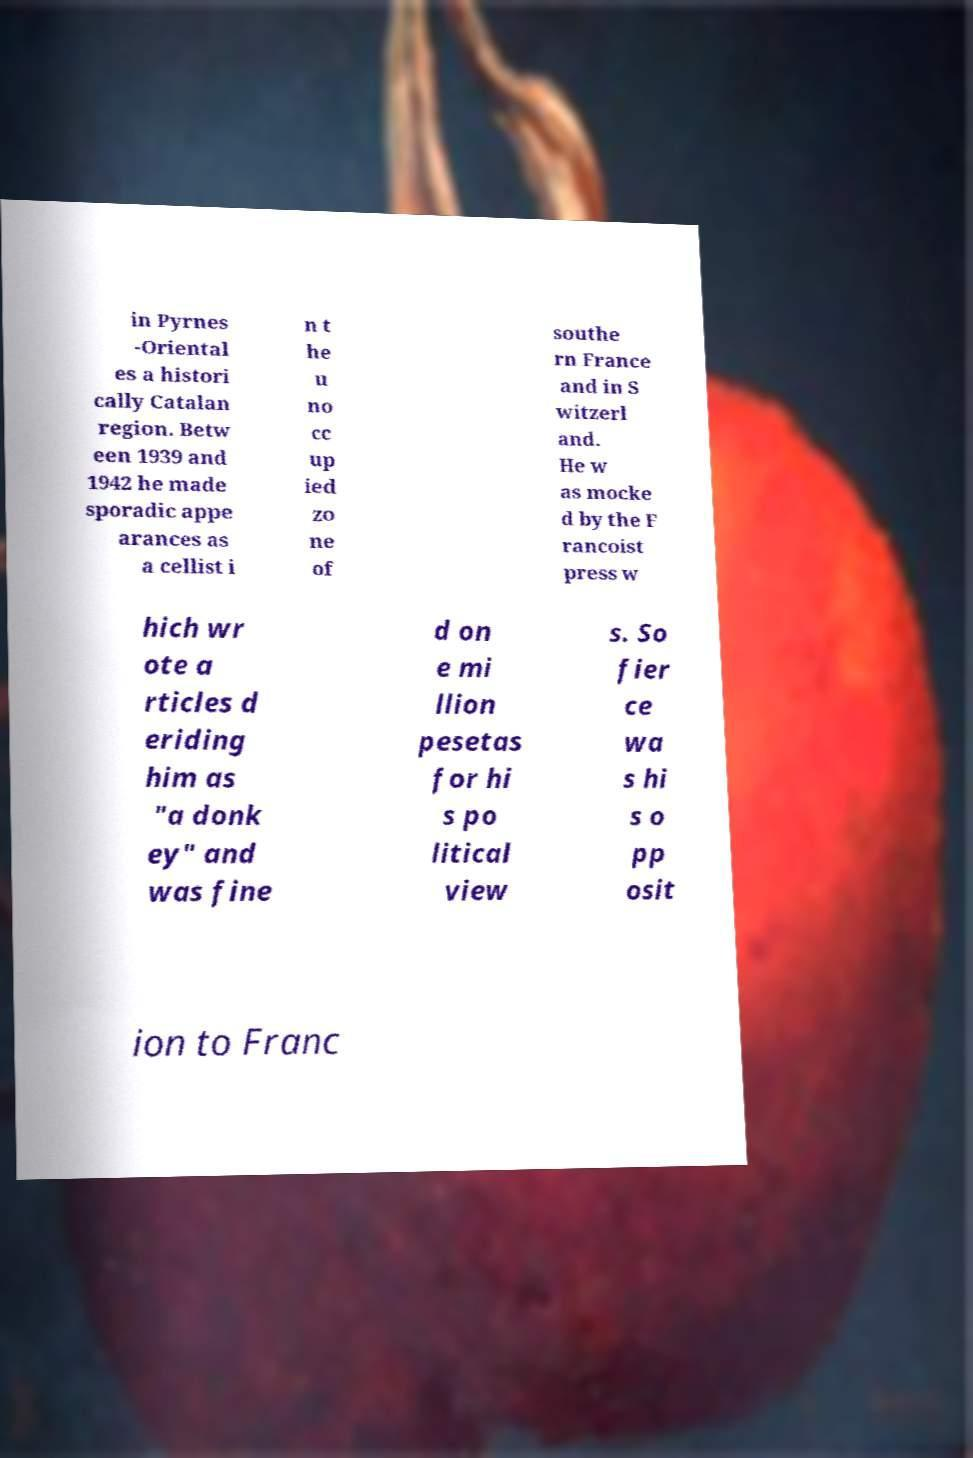What messages or text are displayed in this image? I need them in a readable, typed format. in Pyrnes -Oriental es a histori cally Catalan region. Betw een 1939 and 1942 he made sporadic appe arances as a cellist i n t he u no cc up ied zo ne of southe rn France and in S witzerl and. He w as mocke d by the F rancoist press w hich wr ote a rticles d eriding him as "a donk ey" and was fine d on e mi llion pesetas for hi s po litical view s. So fier ce wa s hi s o pp osit ion to Franc 